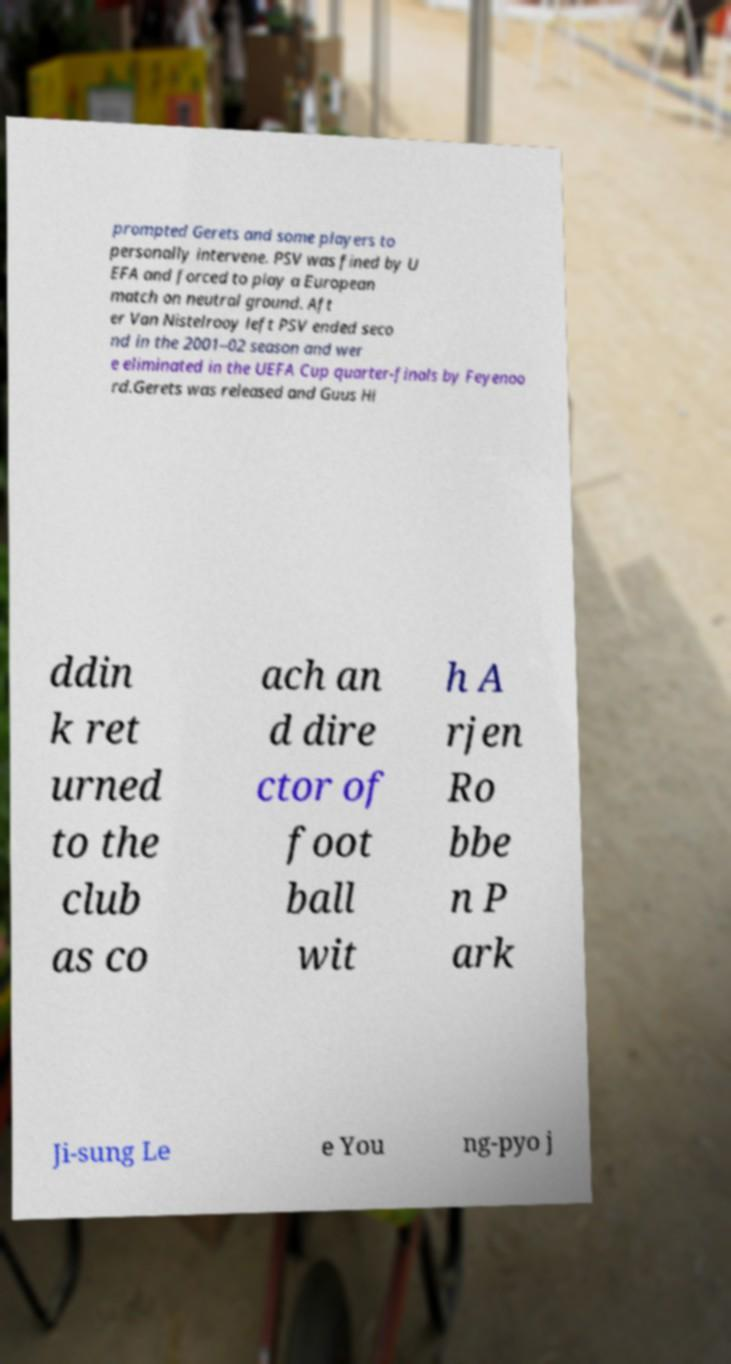For documentation purposes, I need the text within this image transcribed. Could you provide that? prompted Gerets and some players to personally intervene. PSV was fined by U EFA and forced to play a European match on neutral ground. Aft er Van Nistelrooy left PSV ended seco nd in the 2001–02 season and wer e eliminated in the UEFA Cup quarter-finals by Feyenoo rd.Gerets was released and Guus Hi ddin k ret urned to the club as co ach an d dire ctor of foot ball wit h A rjen Ro bbe n P ark Ji-sung Le e You ng-pyo j 